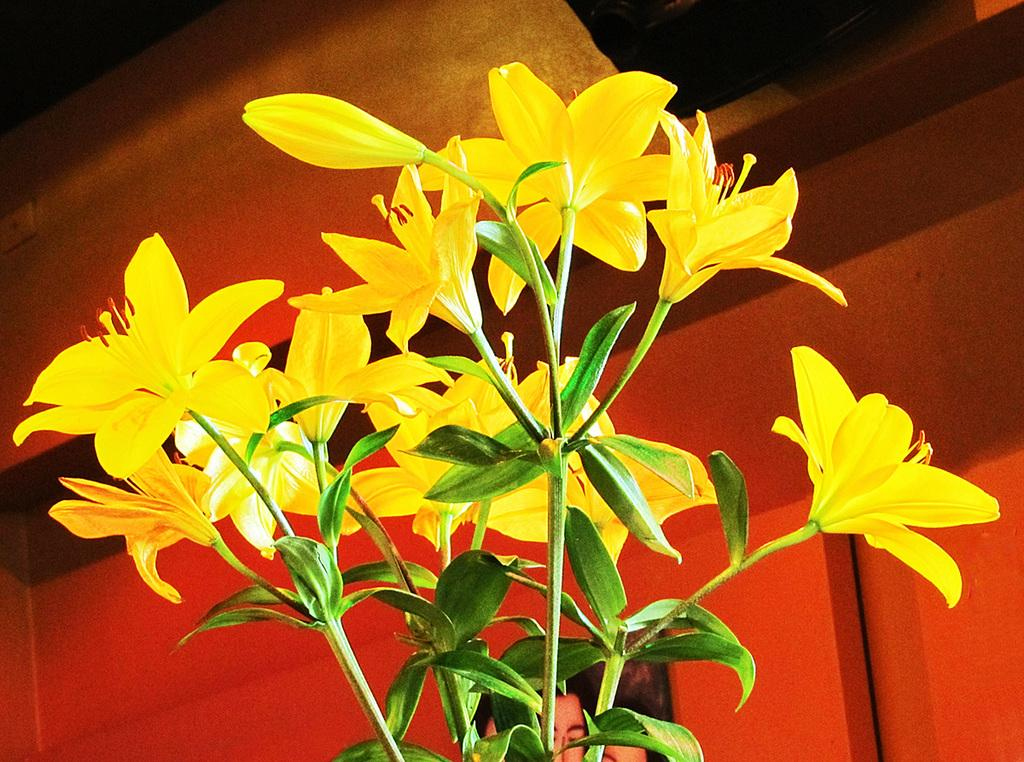What type of plant is depicted in the image? There are stems with yellow flowers and leaves in the image. What can be seen in the background of the image? There is a wall with a frame in the background of the image. What type of smile can be seen on the arm in the image? There is no arm or smile present in the image; it only features stems with yellow flowers and leaves, along with a wall and frame in the background. 